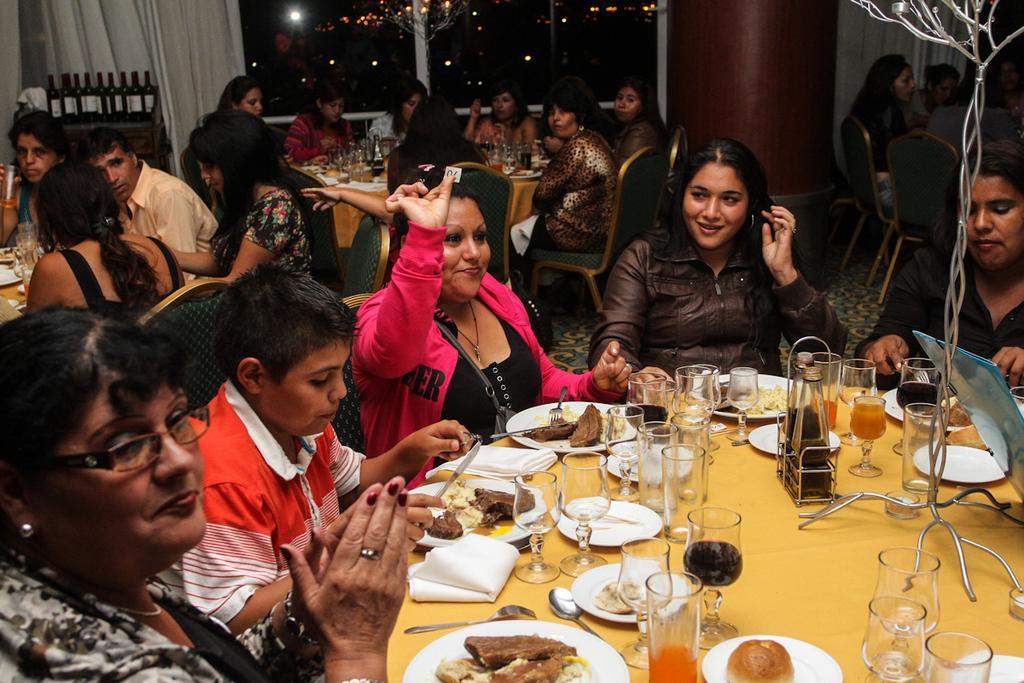In one or two sentences, can you explain what this image depicts? The image is taken in the restaurant. In the center of the image there is a table and there are many people sitting around the table. There are chairs. On the table we can see glasses, spoons, forks, plates, napkins and some food. In the background there is a pillar, curtain and some bottles which are placed on the stand. 